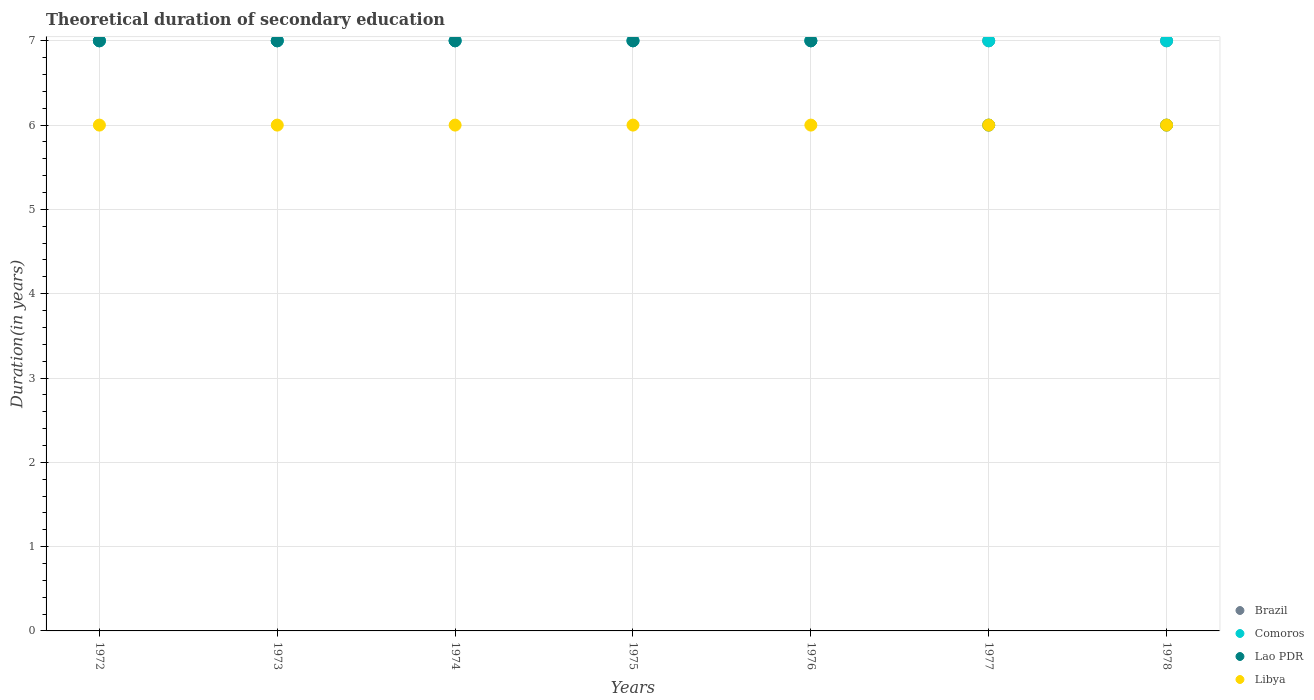How many different coloured dotlines are there?
Provide a succinct answer. 4. What is the total theoretical duration of secondary education in Lao PDR in 1977?
Make the answer very short. 6. Across all years, what is the minimum total theoretical duration of secondary education in Comoros?
Give a very brief answer. 7. In which year was the total theoretical duration of secondary education in Comoros minimum?
Make the answer very short. 1972. What is the total total theoretical duration of secondary education in Comoros in the graph?
Give a very brief answer. 49. What is the difference between the total theoretical duration of secondary education in Comoros in 1977 and that in 1978?
Your answer should be very brief. 0. What is the difference between the total theoretical duration of secondary education in Brazil in 1973 and the total theoretical duration of secondary education in Libya in 1975?
Give a very brief answer. 1. In the year 1975, what is the difference between the total theoretical duration of secondary education in Comoros and total theoretical duration of secondary education in Libya?
Give a very brief answer. 1. In how many years, is the total theoretical duration of secondary education in Lao PDR greater than 5.4 years?
Make the answer very short. 7. Is the total theoretical duration of secondary education in Lao PDR in 1975 less than that in 1976?
Offer a very short reply. No. Is the difference between the total theoretical duration of secondary education in Comoros in 1973 and 1977 greater than the difference between the total theoretical duration of secondary education in Libya in 1973 and 1977?
Your answer should be very brief. No. In how many years, is the total theoretical duration of secondary education in Brazil greater than the average total theoretical duration of secondary education in Brazil taken over all years?
Provide a succinct answer. 0. Is the sum of the total theoretical duration of secondary education in Brazil in 1974 and 1976 greater than the maximum total theoretical duration of secondary education in Libya across all years?
Your answer should be compact. Yes. Is it the case that in every year, the sum of the total theoretical duration of secondary education in Brazil and total theoretical duration of secondary education in Libya  is greater than the sum of total theoretical duration of secondary education in Comoros and total theoretical duration of secondary education in Lao PDR?
Offer a terse response. Yes. Does the total theoretical duration of secondary education in Libya monotonically increase over the years?
Your answer should be compact. No. How many dotlines are there?
Provide a succinct answer. 4. How many years are there in the graph?
Offer a terse response. 7. Are the values on the major ticks of Y-axis written in scientific E-notation?
Provide a succinct answer. No. Does the graph contain any zero values?
Your answer should be compact. No. Does the graph contain grids?
Ensure brevity in your answer.  Yes. Where does the legend appear in the graph?
Provide a succinct answer. Bottom right. How many legend labels are there?
Keep it short and to the point. 4. How are the legend labels stacked?
Your response must be concise. Vertical. What is the title of the graph?
Your answer should be compact. Theoretical duration of secondary education. What is the label or title of the X-axis?
Provide a succinct answer. Years. What is the label or title of the Y-axis?
Give a very brief answer. Duration(in years). What is the Duration(in years) in Comoros in 1972?
Ensure brevity in your answer.  7. What is the Duration(in years) in Lao PDR in 1972?
Make the answer very short. 7. What is the Duration(in years) of Libya in 1972?
Your response must be concise. 6. What is the Duration(in years) in Libya in 1973?
Give a very brief answer. 6. What is the Duration(in years) of Comoros in 1974?
Provide a short and direct response. 7. What is the Duration(in years) in Libya in 1974?
Provide a succinct answer. 6. What is the Duration(in years) in Brazil in 1975?
Keep it short and to the point. 7. What is the Duration(in years) of Comoros in 1975?
Offer a terse response. 7. What is the Duration(in years) of Libya in 1975?
Your answer should be compact. 6. What is the Duration(in years) in Brazil in 1976?
Your response must be concise. 7. What is the Duration(in years) of Comoros in 1976?
Keep it short and to the point. 7. What is the Duration(in years) in Comoros in 1977?
Offer a terse response. 7. What is the Duration(in years) in Lao PDR in 1977?
Your answer should be compact. 6. What is the Duration(in years) in Brazil in 1978?
Your response must be concise. 7. What is the Duration(in years) of Libya in 1978?
Provide a succinct answer. 6. Across all years, what is the maximum Duration(in years) in Lao PDR?
Provide a short and direct response. 7. Across all years, what is the maximum Duration(in years) of Libya?
Provide a succinct answer. 6. Across all years, what is the minimum Duration(in years) in Brazil?
Your response must be concise. 7. Across all years, what is the minimum Duration(in years) in Libya?
Your answer should be compact. 6. What is the total Duration(in years) in Libya in the graph?
Ensure brevity in your answer.  42. What is the difference between the Duration(in years) of Comoros in 1972 and that in 1973?
Ensure brevity in your answer.  0. What is the difference between the Duration(in years) of Libya in 1972 and that in 1973?
Your answer should be very brief. 0. What is the difference between the Duration(in years) of Brazil in 1972 and that in 1974?
Offer a terse response. 0. What is the difference between the Duration(in years) in Lao PDR in 1972 and that in 1974?
Give a very brief answer. 0. What is the difference between the Duration(in years) in Libya in 1972 and that in 1974?
Make the answer very short. 0. What is the difference between the Duration(in years) in Comoros in 1972 and that in 1975?
Provide a short and direct response. 0. What is the difference between the Duration(in years) in Comoros in 1972 and that in 1976?
Offer a terse response. 0. What is the difference between the Duration(in years) in Lao PDR in 1972 and that in 1976?
Offer a terse response. 0. What is the difference between the Duration(in years) of Brazil in 1972 and that in 1977?
Provide a short and direct response. 0. What is the difference between the Duration(in years) of Comoros in 1972 and that in 1977?
Keep it short and to the point. 0. What is the difference between the Duration(in years) in Brazil in 1972 and that in 1978?
Give a very brief answer. 0. What is the difference between the Duration(in years) in Comoros in 1972 and that in 1978?
Offer a very short reply. 0. What is the difference between the Duration(in years) of Brazil in 1973 and that in 1975?
Ensure brevity in your answer.  0. What is the difference between the Duration(in years) in Comoros in 1973 and that in 1975?
Offer a terse response. 0. What is the difference between the Duration(in years) of Lao PDR in 1973 and that in 1975?
Make the answer very short. 0. What is the difference between the Duration(in years) of Lao PDR in 1973 and that in 1976?
Offer a very short reply. 0. What is the difference between the Duration(in years) of Libya in 1973 and that in 1976?
Offer a very short reply. 0. What is the difference between the Duration(in years) in Comoros in 1973 and that in 1977?
Make the answer very short. 0. What is the difference between the Duration(in years) of Lao PDR in 1973 and that in 1977?
Provide a succinct answer. 1. What is the difference between the Duration(in years) of Libya in 1973 and that in 1977?
Keep it short and to the point. 0. What is the difference between the Duration(in years) of Brazil in 1973 and that in 1978?
Your response must be concise. 0. What is the difference between the Duration(in years) in Comoros in 1973 and that in 1978?
Your answer should be compact. 0. What is the difference between the Duration(in years) in Libya in 1973 and that in 1978?
Ensure brevity in your answer.  0. What is the difference between the Duration(in years) in Comoros in 1974 and that in 1975?
Keep it short and to the point. 0. What is the difference between the Duration(in years) in Lao PDR in 1974 and that in 1976?
Your answer should be compact. 0. What is the difference between the Duration(in years) of Libya in 1974 and that in 1976?
Give a very brief answer. 0. What is the difference between the Duration(in years) in Comoros in 1974 and that in 1977?
Give a very brief answer. 0. What is the difference between the Duration(in years) of Comoros in 1974 and that in 1978?
Give a very brief answer. 0. What is the difference between the Duration(in years) of Lao PDR in 1974 and that in 1978?
Keep it short and to the point. 1. What is the difference between the Duration(in years) in Libya in 1975 and that in 1976?
Ensure brevity in your answer.  0. What is the difference between the Duration(in years) in Comoros in 1975 and that in 1977?
Make the answer very short. 0. What is the difference between the Duration(in years) in Libya in 1975 and that in 1977?
Your answer should be compact. 0. What is the difference between the Duration(in years) of Brazil in 1975 and that in 1978?
Make the answer very short. 0. What is the difference between the Duration(in years) of Comoros in 1975 and that in 1978?
Provide a short and direct response. 0. What is the difference between the Duration(in years) in Libya in 1975 and that in 1978?
Your answer should be compact. 0. What is the difference between the Duration(in years) of Brazil in 1976 and that in 1977?
Your answer should be very brief. 0. What is the difference between the Duration(in years) of Comoros in 1976 and that in 1977?
Provide a short and direct response. 0. What is the difference between the Duration(in years) of Libya in 1976 and that in 1977?
Keep it short and to the point. 0. What is the difference between the Duration(in years) in Brazil in 1976 and that in 1978?
Your answer should be compact. 0. What is the difference between the Duration(in years) in Lao PDR in 1976 and that in 1978?
Provide a succinct answer. 1. What is the difference between the Duration(in years) in Brazil in 1977 and that in 1978?
Your response must be concise. 0. What is the difference between the Duration(in years) in Lao PDR in 1977 and that in 1978?
Provide a short and direct response. 0. What is the difference between the Duration(in years) of Libya in 1977 and that in 1978?
Keep it short and to the point. 0. What is the difference between the Duration(in years) in Comoros in 1972 and the Duration(in years) in Libya in 1973?
Your answer should be compact. 1. What is the difference between the Duration(in years) in Brazil in 1972 and the Duration(in years) in Comoros in 1974?
Provide a succinct answer. 0. What is the difference between the Duration(in years) of Brazil in 1972 and the Duration(in years) of Comoros in 1975?
Ensure brevity in your answer.  0. What is the difference between the Duration(in years) in Comoros in 1972 and the Duration(in years) in Libya in 1975?
Provide a short and direct response. 1. What is the difference between the Duration(in years) in Comoros in 1972 and the Duration(in years) in Lao PDR in 1976?
Offer a terse response. 0. What is the difference between the Duration(in years) of Brazil in 1972 and the Duration(in years) of Comoros in 1977?
Make the answer very short. 0. What is the difference between the Duration(in years) in Brazil in 1972 and the Duration(in years) in Lao PDR in 1977?
Give a very brief answer. 1. What is the difference between the Duration(in years) of Comoros in 1972 and the Duration(in years) of Libya in 1977?
Offer a terse response. 1. What is the difference between the Duration(in years) of Brazil in 1972 and the Duration(in years) of Comoros in 1978?
Keep it short and to the point. 0. What is the difference between the Duration(in years) in Lao PDR in 1972 and the Duration(in years) in Libya in 1978?
Provide a short and direct response. 1. What is the difference between the Duration(in years) in Brazil in 1973 and the Duration(in years) in Comoros in 1974?
Provide a succinct answer. 0. What is the difference between the Duration(in years) in Brazil in 1973 and the Duration(in years) in Libya in 1974?
Provide a short and direct response. 1. What is the difference between the Duration(in years) of Comoros in 1973 and the Duration(in years) of Lao PDR in 1974?
Provide a short and direct response. 0. What is the difference between the Duration(in years) in Lao PDR in 1973 and the Duration(in years) in Libya in 1974?
Offer a terse response. 1. What is the difference between the Duration(in years) of Brazil in 1973 and the Duration(in years) of Lao PDR in 1975?
Keep it short and to the point. 0. What is the difference between the Duration(in years) in Comoros in 1973 and the Duration(in years) in Lao PDR in 1975?
Offer a terse response. 0. What is the difference between the Duration(in years) in Comoros in 1973 and the Duration(in years) in Libya in 1975?
Make the answer very short. 1. What is the difference between the Duration(in years) of Lao PDR in 1973 and the Duration(in years) of Libya in 1975?
Provide a succinct answer. 1. What is the difference between the Duration(in years) of Brazil in 1973 and the Duration(in years) of Libya in 1976?
Give a very brief answer. 1. What is the difference between the Duration(in years) in Lao PDR in 1973 and the Duration(in years) in Libya in 1976?
Provide a short and direct response. 1. What is the difference between the Duration(in years) of Brazil in 1973 and the Duration(in years) of Lao PDR in 1977?
Offer a very short reply. 1. What is the difference between the Duration(in years) of Comoros in 1973 and the Duration(in years) of Libya in 1977?
Keep it short and to the point. 1. What is the difference between the Duration(in years) of Brazil in 1974 and the Duration(in years) of Comoros in 1975?
Your response must be concise. 0. What is the difference between the Duration(in years) of Brazil in 1974 and the Duration(in years) of Lao PDR in 1975?
Ensure brevity in your answer.  0. What is the difference between the Duration(in years) of Brazil in 1974 and the Duration(in years) of Libya in 1975?
Ensure brevity in your answer.  1. What is the difference between the Duration(in years) in Lao PDR in 1974 and the Duration(in years) in Libya in 1975?
Ensure brevity in your answer.  1. What is the difference between the Duration(in years) of Brazil in 1974 and the Duration(in years) of Lao PDR in 1976?
Your answer should be compact. 0. What is the difference between the Duration(in years) of Brazil in 1974 and the Duration(in years) of Libya in 1976?
Your answer should be very brief. 1. What is the difference between the Duration(in years) in Comoros in 1974 and the Duration(in years) in Lao PDR in 1976?
Your answer should be very brief. 0. What is the difference between the Duration(in years) of Comoros in 1974 and the Duration(in years) of Libya in 1976?
Make the answer very short. 1. What is the difference between the Duration(in years) in Brazil in 1974 and the Duration(in years) in Lao PDR in 1977?
Provide a short and direct response. 1. What is the difference between the Duration(in years) of Comoros in 1974 and the Duration(in years) of Lao PDR in 1977?
Provide a succinct answer. 1. What is the difference between the Duration(in years) of Comoros in 1974 and the Duration(in years) of Libya in 1977?
Ensure brevity in your answer.  1. What is the difference between the Duration(in years) of Brazil in 1974 and the Duration(in years) of Comoros in 1978?
Make the answer very short. 0. What is the difference between the Duration(in years) in Brazil in 1975 and the Duration(in years) in Comoros in 1976?
Offer a terse response. 0. What is the difference between the Duration(in years) of Brazil in 1975 and the Duration(in years) of Lao PDR in 1976?
Your answer should be very brief. 0. What is the difference between the Duration(in years) in Comoros in 1975 and the Duration(in years) in Libya in 1976?
Provide a succinct answer. 1. What is the difference between the Duration(in years) in Brazil in 1975 and the Duration(in years) in Comoros in 1977?
Your answer should be compact. 0. What is the difference between the Duration(in years) of Brazil in 1975 and the Duration(in years) of Libya in 1977?
Your response must be concise. 1. What is the difference between the Duration(in years) of Comoros in 1975 and the Duration(in years) of Lao PDR in 1977?
Your answer should be compact. 1. What is the difference between the Duration(in years) of Comoros in 1975 and the Duration(in years) of Libya in 1977?
Offer a terse response. 1. What is the difference between the Duration(in years) of Lao PDR in 1975 and the Duration(in years) of Libya in 1977?
Ensure brevity in your answer.  1. What is the difference between the Duration(in years) of Brazil in 1975 and the Duration(in years) of Comoros in 1978?
Offer a very short reply. 0. What is the difference between the Duration(in years) in Brazil in 1975 and the Duration(in years) in Lao PDR in 1978?
Your answer should be very brief. 1. What is the difference between the Duration(in years) of Brazil in 1975 and the Duration(in years) of Libya in 1978?
Your response must be concise. 1. What is the difference between the Duration(in years) of Brazil in 1976 and the Duration(in years) of Comoros in 1977?
Offer a very short reply. 0. What is the difference between the Duration(in years) of Brazil in 1976 and the Duration(in years) of Libya in 1977?
Keep it short and to the point. 1. What is the difference between the Duration(in years) in Comoros in 1976 and the Duration(in years) in Libya in 1977?
Make the answer very short. 1. What is the difference between the Duration(in years) of Lao PDR in 1976 and the Duration(in years) of Libya in 1977?
Keep it short and to the point. 1. What is the difference between the Duration(in years) of Brazil in 1976 and the Duration(in years) of Comoros in 1978?
Provide a succinct answer. 0. What is the difference between the Duration(in years) in Brazil in 1976 and the Duration(in years) in Libya in 1978?
Your answer should be compact. 1. What is the difference between the Duration(in years) of Comoros in 1976 and the Duration(in years) of Lao PDR in 1978?
Ensure brevity in your answer.  1. What is the difference between the Duration(in years) of Comoros in 1976 and the Duration(in years) of Libya in 1978?
Offer a terse response. 1. What is the difference between the Duration(in years) in Brazil in 1977 and the Duration(in years) in Lao PDR in 1978?
Make the answer very short. 1. What is the difference between the Duration(in years) of Brazil in 1977 and the Duration(in years) of Libya in 1978?
Provide a short and direct response. 1. What is the difference between the Duration(in years) in Comoros in 1977 and the Duration(in years) in Lao PDR in 1978?
Your answer should be compact. 1. What is the difference between the Duration(in years) in Lao PDR in 1977 and the Duration(in years) in Libya in 1978?
Give a very brief answer. 0. What is the average Duration(in years) of Brazil per year?
Provide a succinct answer. 7. What is the average Duration(in years) in Comoros per year?
Your answer should be compact. 7. What is the average Duration(in years) in Lao PDR per year?
Offer a terse response. 6.71. What is the average Duration(in years) of Libya per year?
Provide a short and direct response. 6. In the year 1972, what is the difference between the Duration(in years) in Brazil and Duration(in years) in Lao PDR?
Offer a terse response. 0. In the year 1973, what is the difference between the Duration(in years) in Brazil and Duration(in years) in Comoros?
Ensure brevity in your answer.  0. In the year 1973, what is the difference between the Duration(in years) of Brazil and Duration(in years) of Libya?
Make the answer very short. 1. In the year 1973, what is the difference between the Duration(in years) of Comoros and Duration(in years) of Lao PDR?
Offer a terse response. 0. In the year 1973, what is the difference between the Duration(in years) in Lao PDR and Duration(in years) in Libya?
Provide a succinct answer. 1. In the year 1974, what is the difference between the Duration(in years) of Brazil and Duration(in years) of Comoros?
Your response must be concise. 0. In the year 1974, what is the difference between the Duration(in years) of Brazil and Duration(in years) of Lao PDR?
Keep it short and to the point. 0. In the year 1974, what is the difference between the Duration(in years) in Comoros and Duration(in years) in Lao PDR?
Give a very brief answer. 0. In the year 1974, what is the difference between the Duration(in years) in Comoros and Duration(in years) in Libya?
Your answer should be very brief. 1. In the year 1974, what is the difference between the Duration(in years) of Lao PDR and Duration(in years) of Libya?
Make the answer very short. 1. In the year 1975, what is the difference between the Duration(in years) in Brazil and Duration(in years) in Lao PDR?
Keep it short and to the point. 0. In the year 1975, what is the difference between the Duration(in years) in Brazil and Duration(in years) in Libya?
Offer a very short reply. 1. In the year 1975, what is the difference between the Duration(in years) of Comoros and Duration(in years) of Lao PDR?
Ensure brevity in your answer.  0. In the year 1976, what is the difference between the Duration(in years) in Comoros and Duration(in years) in Lao PDR?
Your answer should be compact. 0. In the year 1976, what is the difference between the Duration(in years) of Comoros and Duration(in years) of Libya?
Your answer should be very brief. 1. In the year 1976, what is the difference between the Duration(in years) of Lao PDR and Duration(in years) of Libya?
Offer a very short reply. 1. In the year 1977, what is the difference between the Duration(in years) of Brazil and Duration(in years) of Libya?
Offer a terse response. 1. In the year 1978, what is the difference between the Duration(in years) of Lao PDR and Duration(in years) of Libya?
Provide a succinct answer. 0. What is the ratio of the Duration(in years) in Comoros in 1972 to that in 1973?
Your answer should be very brief. 1. What is the ratio of the Duration(in years) of Lao PDR in 1972 to that in 1973?
Make the answer very short. 1. What is the ratio of the Duration(in years) in Libya in 1972 to that in 1973?
Your answer should be very brief. 1. What is the ratio of the Duration(in years) of Comoros in 1972 to that in 1974?
Your response must be concise. 1. What is the ratio of the Duration(in years) of Lao PDR in 1972 to that in 1974?
Your response must be concise. 1. What is the ratio of the Duration(in years) of Brazil in 1972 to that in 1976?
Give a very brief answer. 1. What is the ratio of the Duration(in years) in Comoros in 1972 to that in 1976?
Give a very brief answer. 1. What is the ratio of the Duration(in years) of Lao PDR in 1972 to that in 1976?
Ensure brevity in your answer.  1. What is the ratio of the Duration(in years) of Libya in 1972 to that in 1976?
Offer a very short reply. 1. What is the ratio of the Duration(in years) in Brazil in 1972 to that in 1977?
Your answer should be compact. 1. What is the ratio of the Duration(in years) in Comoros in 1972 to that in 1977?
Offer a terse response. 1. What is the ratio of the Duration(in years) in Brazil in 1972 to that in 1978?
Provide a short and direct response. 1. What is the ratio of the Duration(in years) in Brazil in 1973 to that in 1975?
Keep it short and to the point. 1. What is the ratio of the Duration(in years) of Comoros in 1973 to that in 1975?
Your answer should be compact. 1. What is the ratio of the Duration(in years) of Lao PDR in 1973 to that in 1975?
Your answer should be compact. 1. What is the ratio of the Duration(in years) in Brazil in 1973 to that in 1976?
Offer a terse response. 1. What is the ratio of the Duration(in years) in Comoros in 1973 to that in 1977?
Your response must be concise. 1. What is the ratio of the Duration(in years) in Lao PDR in 1973 to that in 1977?
Provide a succinct answer. 1.17. What is the ratio of the Duration(in years) in Brazil in 1973 to that in 1978?
Your response must be concise. 1. What is the ratio of the Duration(in years) in Libya in 1973 to that in 1978?
Your answer should be very brief. 1. What is the ratio of the Duration(in years) of Brazil in 1974 to that in 1975?
Offer a terse response. 1. What is the ratio of the Duration(in years) of Brazil in 1974 to that in 1976?
Your answer should be compact. 1. What is the ratio of the Duration(in years) of Comoros in 1974 to that in 1976?
Your response must be concise. 1. What is the ratio of the Duration(in years) of Libya in 1974 to that in 1977?
Your response must be concise. 1. What is the ratio of the Duration(in years) of Lao PDR in 1974 to that in 1978?
Your response must be concise. 1.17. What is the ratio of the Duration(in years) of Brazil in 1975 to that in 1976?
Make the answer very short. 1. What is the ratio of the Duration(in years) in Lao PDR in 1975 to that in 1976?
Ensure brevity in your answer.  1. What is the ratio of the Duration(in years) in Comoros in 1975 to that in 1977?
Your answer should be compact. 1. What is the ratio of the Duration(in years) of Lao PDR in 1975 to that in 1977?
Offer a terse response. 1.17. What is the ratio of the Duration(in years) of Libya in 1975 to that in 1977?
Make the answer very short. 1. What is the ratio of the Duration(in years) of Comoros in 1975 to that in 1978?
Provide a succinct answer. 1. What is the ratio of the Duration(in years) in Libya in 1975 to that in 1978?
Your answer should be very brief. 1. What is the ratio of the Duration(in years) of Comoros in 1976 to that in 1977?
Offer a very short reply. 1. What is the ratio of the Duration(in years) of Brazil in 1976 to that in 1978?
Keep it short and to the point. 1. What is the ratio of the Duration(in years) in Comoros in 1976 to that in 1978?
Your answer should be compact. 1. What is the ratio of the Duration(in years) in Libya in 1976 to that in 1978?
Your answer should be compact. 1. What is the ratio of the Duration(in years) of Brazil in 1977 to that in 1978?
Provide a short and direct response. 1. What is the ratio of the Duration(in years) of Comoros in 1977 to that in 1978?
Keep it short and to the point. 1. What is the ratio of the Duration(in years) in Libya in 1977 to that in 1978?
Offer a terse response. 1. What is the difference between the highest and the second highest Duration(in years) of Brazil?
Offer a very short reply. 0. What is the difference between the highest and the second highest Duration(in years) of Comoros?
Your answer should be compact. 0. What is the difference between the highest and the lowest Duration(in years) in Brazil?
Offer a terse response. 0. What is the difference between the highest and the lowest Duration(in years) of Lao PDR?
Offer a terse response. 1. 